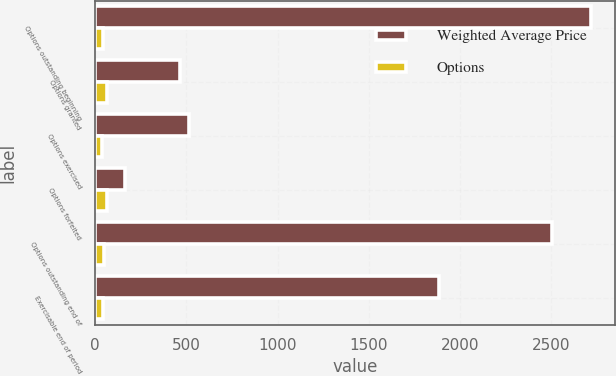<chart> <loc_0><loc_0><loc_500><loc_500><stacked_bar_chart><ecel><fcel>Options outstanding beginning<fcel>Options granted<fcel>Options exercised<fcel>Options forfeited<fcel>Options outstanding end of<fcel>Exercisable end of period<nl><fcel>Weighted Average Price<fcel>2717<fcel>468<fcel>517<fcel>165<fcel>2503<fcel>1888<nl><fcel>Options<fcel>43<fcel>63<fcel>39<fcel>64<fcel>47<fcel>42<nl></chart> 